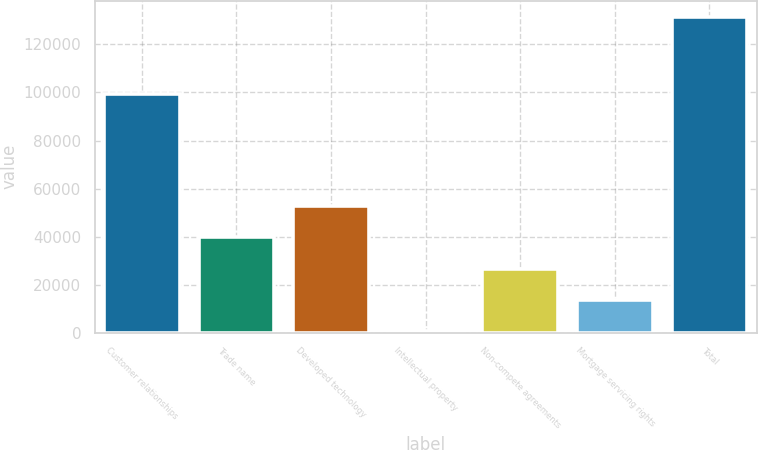<chart> <loc_0><loc_0><loc_500><loc_500><bar_chart><fcel>Customer relationships<fcel>Trade name<fcel>Developed technology<fcel>Intellectual property<fcel>Non-compete agreements<fcel>Mortgage servicing rights<fcel>Total<nl><fcel>99470<fcel>39825<fcel>52928<fcel>516<fcel>26722<fcel>13619<fcel>131546<nl></chart> 